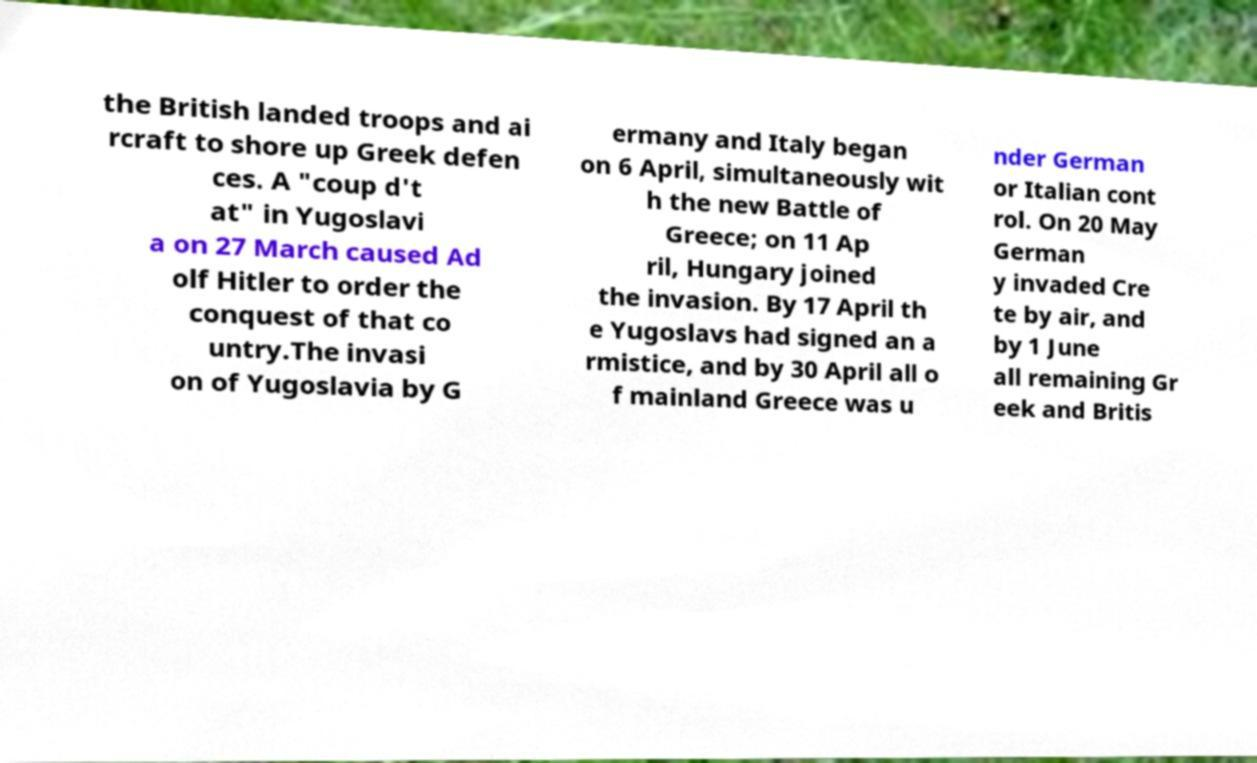For documentation purposes, I need the text within this image transcribed. Could you provide that? the British landed troops and ai rcraft to shore up Greek defen ces. A "coup d't at" in Yugoslavi a on 27 March caused Ad olf Hitler to order the conquest of that co untry.The invasi on of Yugoslavia by G ermany and Italy began on 6 April, simultaneously wit h the new Battle of Greece; on 11 Ap ril, Hungary joined the invasion. By 17 April th e Yugoslavs had signed an a rmistice, and by 30 April all o f mainland Greece was u nder German or Italian cont rol. On 20 May German y invaded Cre te by air, and by 1 June all remaining Gr eek and Britis 